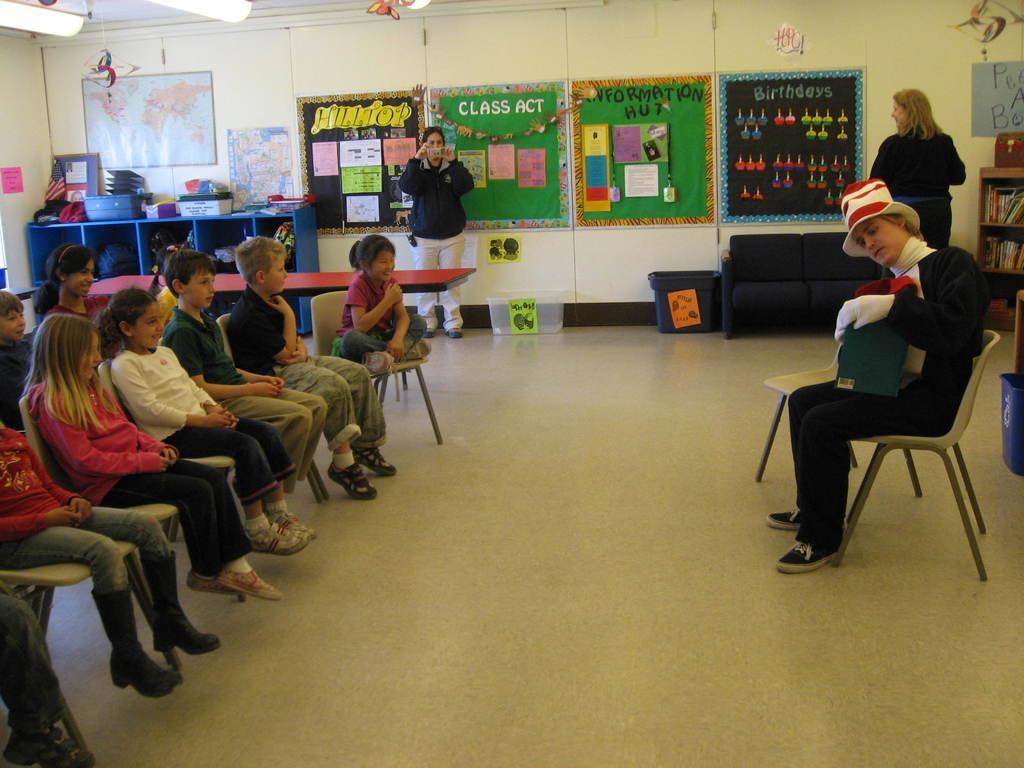How would you summarize this image in a sentence or two? In this image I can see a man and number of children are sitting on chairs. In the background I can see two persons, a table and number of papers on the wall. I can also see something is written on these papers and on the left side I can see blue colour racks. 